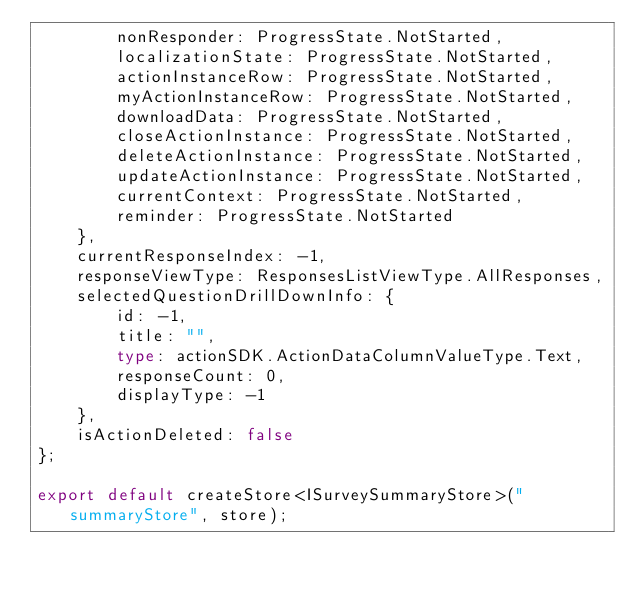Convert code to text. <code><loc_0><loc_0><loc_500><loc_500><_TypeScript_>        nonResponder: ProgressState.NotStarted,
        localizationState: ProgressState.NotStarted,
        actionInstanceRow: ProgressState.NotStarted,
        myActionInstanceRow: ProgressState.NotStarted,
        downloadData: ProgressState.NotStarted,
        closeActionInstance: ProgressState.NotStarted,
        deleteActionInstance: ProgressState.NotStarted,
        updateActionInstance: ProgressState.NotStarted,
        currentContext: ProgressState.NotStarted,
        reminder: ProgressState.NotStarted
    },
    currentResponseIndex: -1,
    responseViewType: ResponsesListViewType.AllResponses,
    selectedQuestionDrillDownInfo: {
        id: -1,
        title: "",
        type: actionSDK.ActionDataColumnValueType.Text,
        responseCount: 0,
        displayType: -1
    },
    isActionDeleted: false
};

export default createStore<ISurveySummaryStore>("summaryStore", store);
</code> 